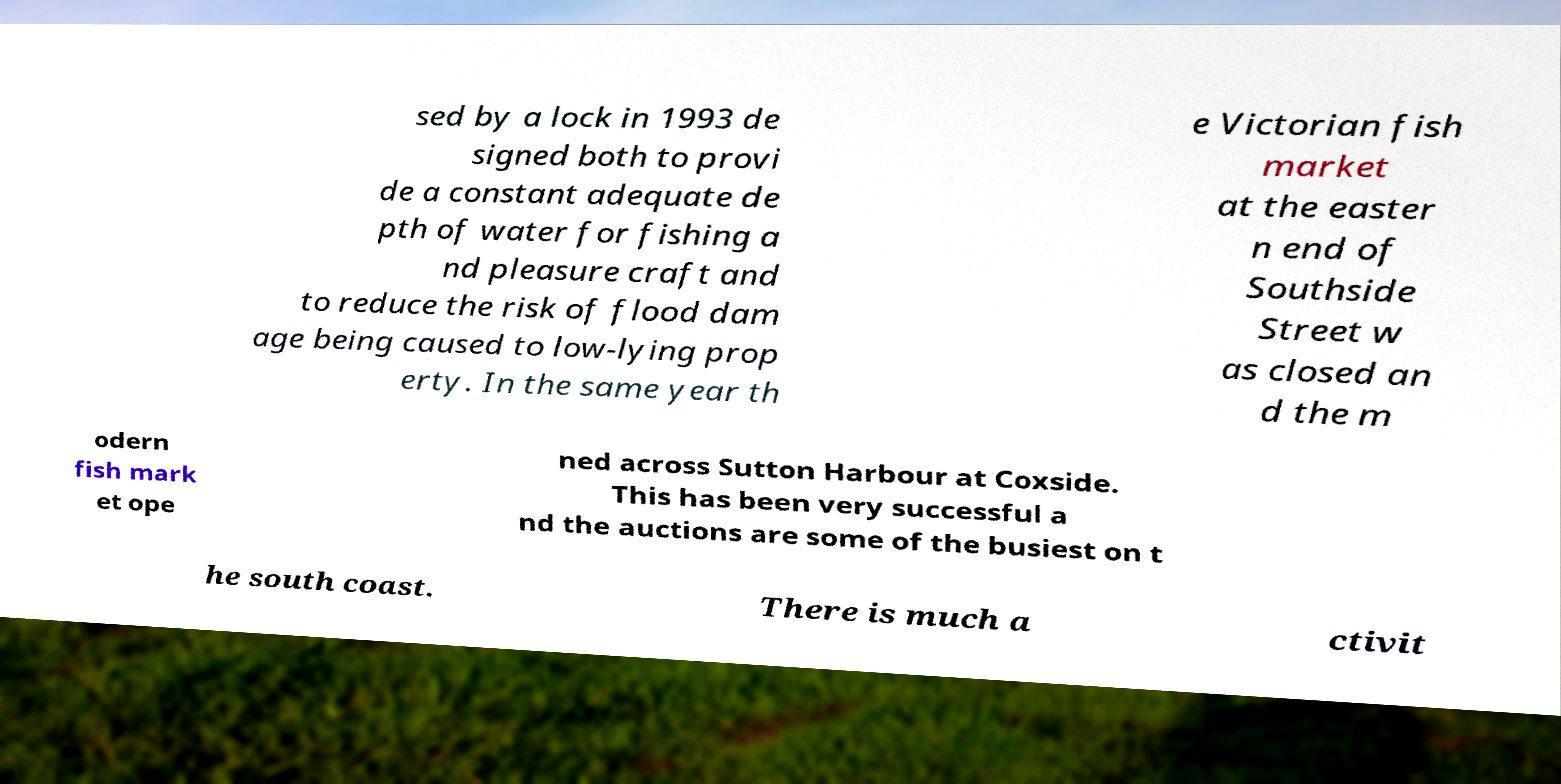Could you assist in decoding the text presented in this image and type it out clearly? sed by a lock in 1993 de signed both to provi de a constant adequate de pth of water for fishing a nd pleasure craft and to reduce the risk of flood dam age being caused to low-lying prop erty. In the same year th e Victorian fish market at the easter n end of Southside Street w as closed an d the m odern fish mark et ope ned across Sutton Harbour at Coxside. This has been very successful a nd the auctions are some of the busiest on t he south coast. There is much a ctivit 